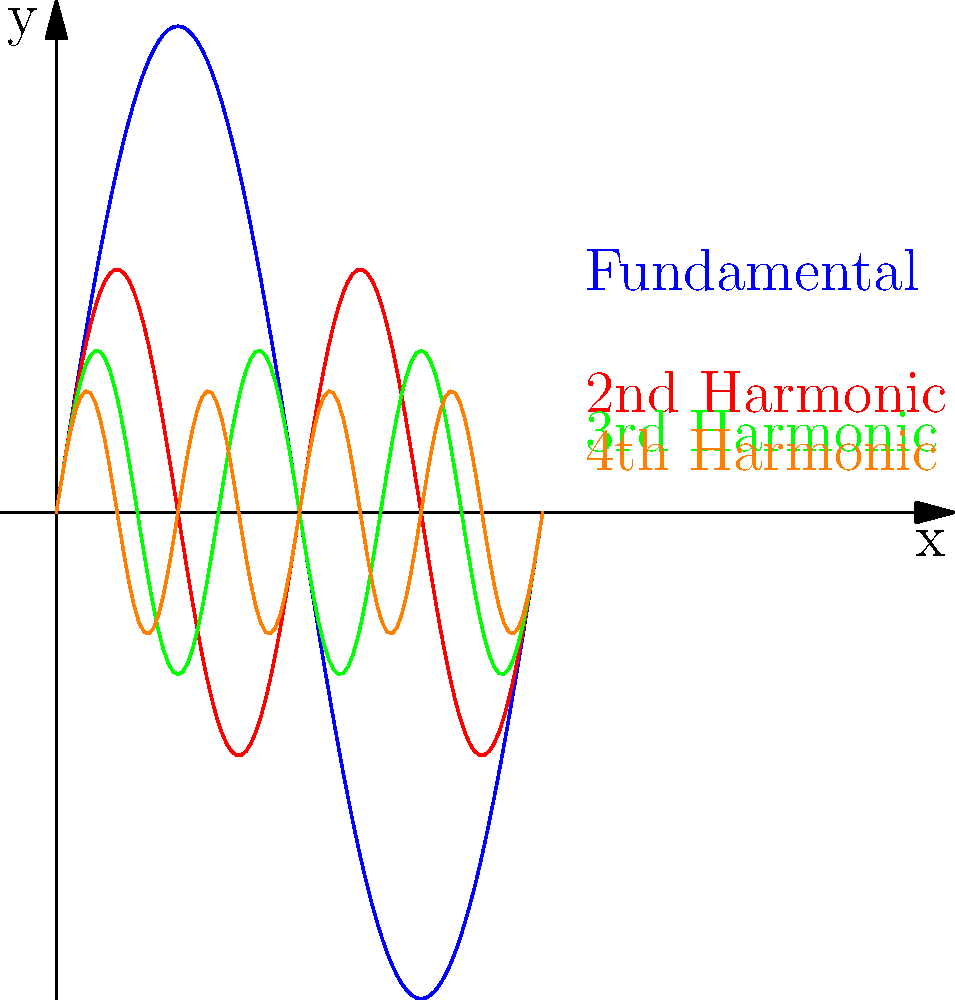Given the harmonic series graph of a vibrating string, calculate the frequency ratio between the fundamental frequency and the 4th harmonic. How does this ratio relate to the concept of musical octaves? To solve this problem, let's follow these steps:

1) In a harmonic series, the frequencies of the harmonics are integer multiples of the fundamental frequency.

2) The fundamental frequency (1st harmonic) is represented by the blue curve.

3) The 4th harmonic is represented by the orange curve.

4) The frequency of the nth harmonic is given by the formula:

   $$f_n = n \cdot f_1$$

   where $f_n$ is the frequency of the nth harmonic and $f_1$ is the fundamental frequency.

5) For the 4th harmonic, n = 4, so:

   $$f_4 = 4 \cdot f_1$$

6) The ratio of the 4th harmonic to the fundamental is thus:

   $$\frac{f_4}{f_1} = \frac{4f_1}{f_1} = 4$$

7) In music theory, an octave is defined as a doubling of frequency. Mathematically, this is a ratio of 2:1.

8) The ratio we found (4:1) represents two octaves, because:

   $$4 = 2 \cdot 2$$

   This means the frequency has doubled twice.

Therefore, the 4th harmonic is two octaves above the fundamental frequency.
Answer: Ratio 4:1; represents 2 octaves 